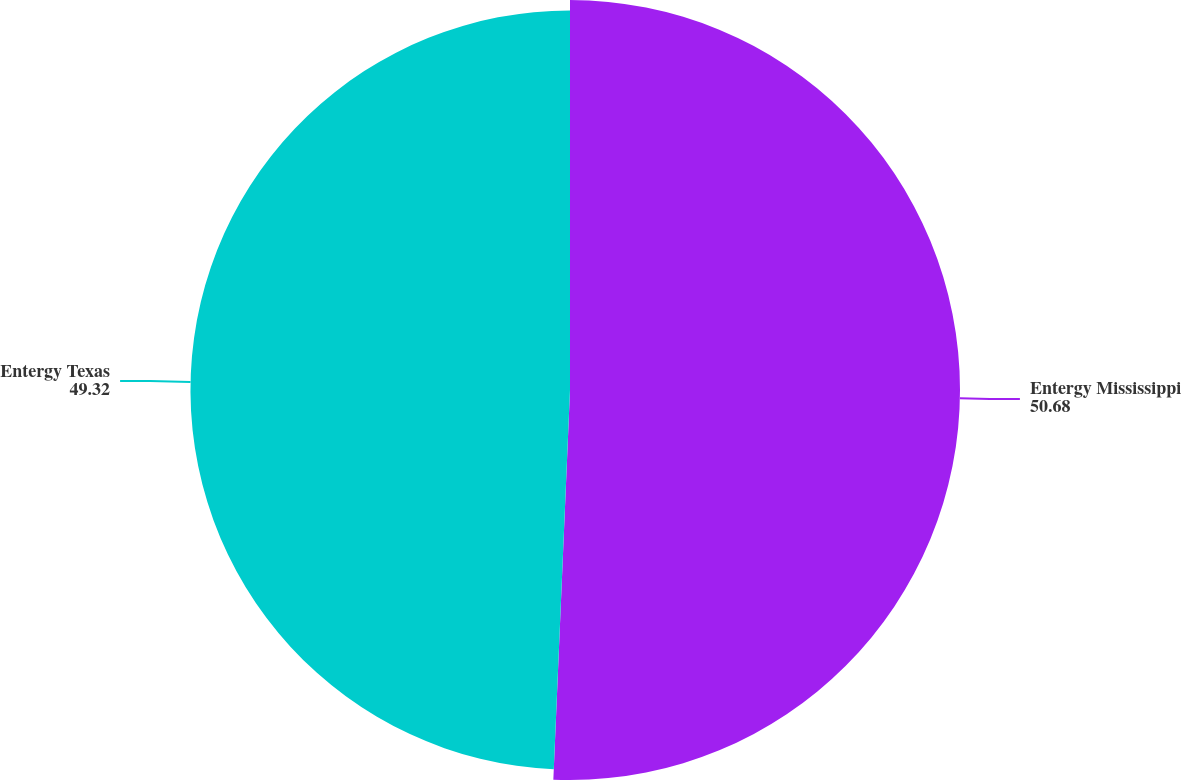<chart> <loc_0><loc_0><loc_500><loc_500><pie_chart><fcel>Entergy Mississippi<fcel>Entergy Texas<nl><fcel>50.68%<fcel>49.32%<nl></chart> 